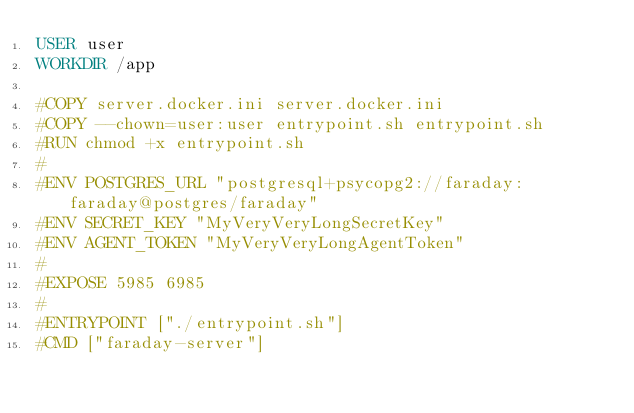<code> <loc_0><loc_0><loc_500><loc_500><_Dockerfile_>USER user
WORKDIR /app

#COPY server.docker.ini server.docker.ini
#COPY --chown=user:user entrypoint.sh entrypoint.sh
#RUN chmod +x entrypoint.sh
#
#ENV POSTGRES_URL "postgresql+psycopg2://faraday:faraday@postgres/faraday"
#ENV SECRET_KEY "MyVeryVeryLongSecretKey"
#ENV AGENT_TOKEN "MyVeryVeryLongAgentToken"
#
#EXPOSE 5985 6985
#
#ENTRYPOINT ["./entrypoint.sh"]
#CMD ["faraday-server"]
</code> 